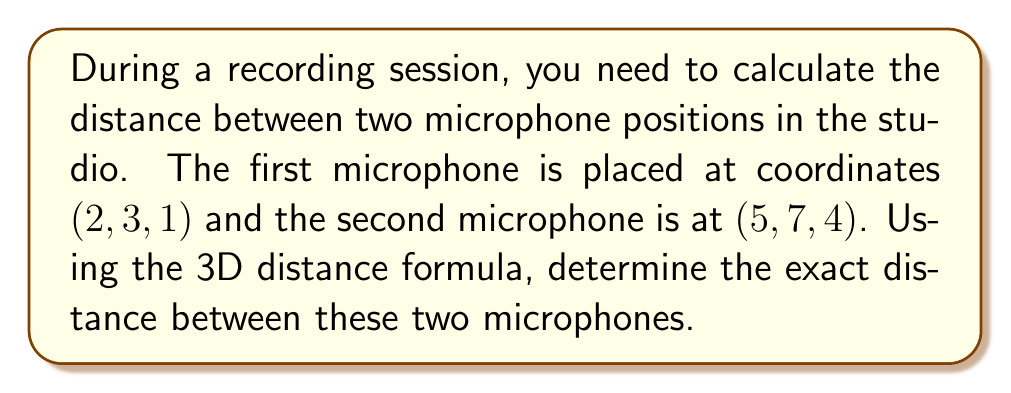Could you help me with this problem? To solve this problem, we'll use the 3D distance formula, which is derived from the Pythagorean theorem extended to three dimensions. The formula is:

$$d = \sqrt{(x_2 - x_1)^2 + (y_2 - y_1)^2 + (z_2 - z_1)^2}$$

Where $(x_1, y_1, z_1)$ are the coordinates of the first point and $(x_2, y_2, z_2)$ are the coordinates of the second point.

Given:
- Microphone 1: $(x_1, y_1, z_1) = (2, 3, 1)$
- Microphone 2: $(x_2, y_2, z_2) = (5, 7, 4)$

Let's substitute these values into the formula:

$$\begin{align}
d &= \sqrt{(5 - 2)^2 + (7 - 3)^2 + (4 - 1)^2} \\[6pt]
&= \sqrt{3^2 + 4^2 + 3^2} \\[6pt]
&= \sqrt{9 + 16 + 9} \\[6pt]
&= \sqrt{34} \\[6pt]
&= \sqrt{2 \cdot 17}
\end{align}$$

The distance between the two microphones is $\sqrt{34}$ or $\sqrt{2 \cdot 17}$ units.
Answer: $\sqrt{34}$ or $\sqrt{2 \cdot 17}$ units 